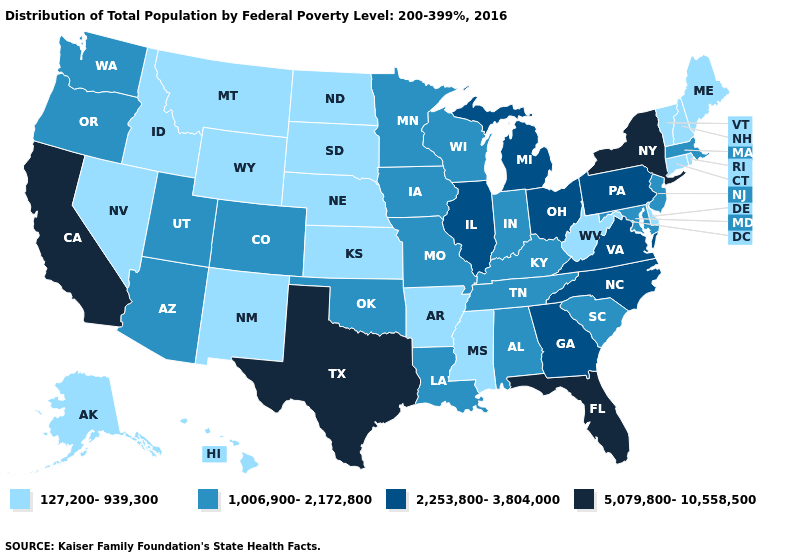What is the value of Louisiana?
Give a very brief answer. 1,006,900-2,172,800. What is the value of Montana?
Write a very short answer. 127,200-939,300. Which states hav the highest value in the West?
Concise answer only. California. What is the value of Kansas?
Keep it brief. 127,200-939,300. Name the states that have a value in the range 1,006,900-2,172,800?
Concise answer only. Alabama, Arizona, Colorado, Indiana, Iowa, Kentucky, Louisiana, Maryland, Massachusetts, Minnesota, Missouri, New Jersey, Oklahoma, Oregon, South Carolina, Tennessee, Utah, Washington, Wisconsin. Does North Dakota have the highest value in the USA?
Write a very short answer. No. Which states have the lowest value in the USA?
Concise answer only. Alaska, Arkansas, Connecticut, Delaware, Hawaii, Idaho, Kansas, Maine, Mississippi, Montana, Nebraska, Nevada, New Hampshire, New Mexico, North Dakota, Rhode Island, South Dakota, Vermont, West Virginia, Wyoming. What is the value of Arkansas?
Concise answer only. 127,200-939,300. Name the states that have a value in the range 1,006,900-2,172,800?
Quick response, please. Alabama, Arizona, Colorado, Indiana, Iowa, Kentucky, Louisiana, Maryland, Massachusetts, Minnesota, Missouri, New Jersey, Oklahoma, Oregon, South Carolina, Tennessee, Utah, Washington, Wisconsin. What is the lowest value in states that border Missouri?
Quick response, please. 127,200-939,300. Name the states that have a value in the range 1,006,900-2,172,800?
Give a very brief answer. Alabama, Arizona, Colorado, Indiana, Iowa, Kentucky, Louisiana, Maryland, Massachusetts, Minnesota, Missouri, New Jersey, Oklahoma, Oregon, South Carolina, Tennessee, Utah, Washington, Wisconsin. What is the value of Tennessee?
Concise answer only. 1,006,900-2,172,800. Does Connecticut have the lowest value in the USA?
Quick response, please. Yes. What is the lowest value in the MidWest?
Short answer required. 127,200-939,300. Name the states that have a value in the range 1,006,900-2,172,800?
Be succinct. Alabama, Arizona, Colorado, Indiana, Iowa, Kentucky, Louisiana, Maryland, Massachusetts, Minnesota, Missouri, New Jersey, Oklahoma, Oregon, South Carolina, Tennessee, Utah, Washington, Wisconsin. 